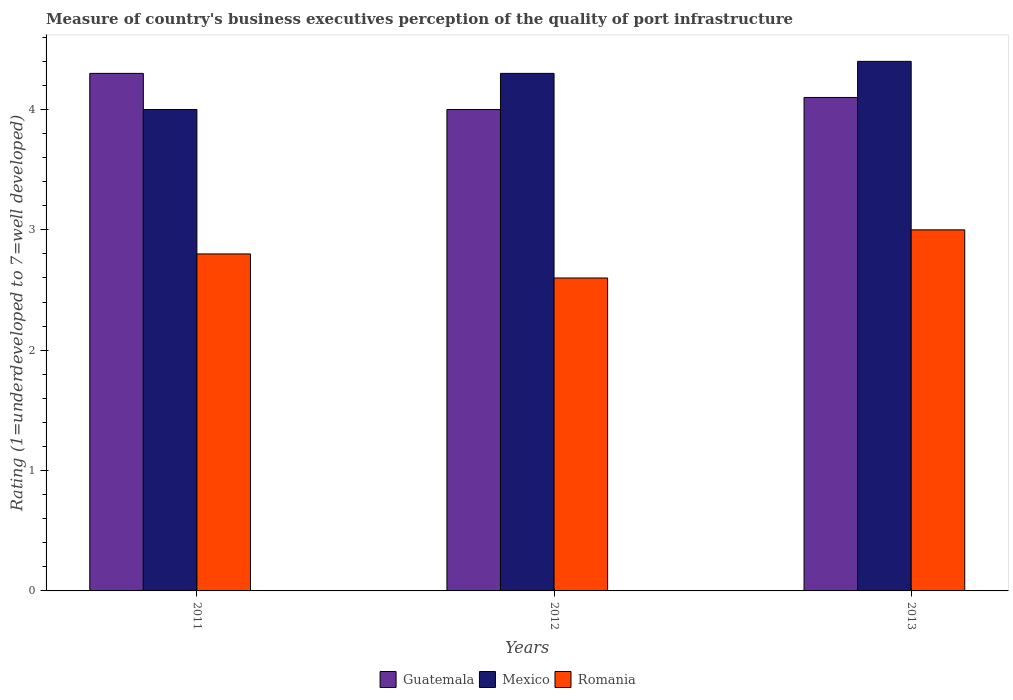Are the number of bars on each tick of the X-axis equal?
Offer a very short reply. Yes. What is the label of the 2nd group of bars from the left?
Keep it short and to the point. 2012. What is the difference between the ratings of the quality of port infrastructure in Romania in 2011 and that in 2012?
Make the answer very short. 0.2. What is the difference between the ratings of the quality of port infrastructure in Guatemala in 2011 and the ratings of the quality of port infrastructure in Romania in 2013?
Give a very brief answer. 1.3. What is the average ratings of the quality of port infrastructure in Mexico per year?
Provide a short and direct response. 4.23. In the year 2013, what is the difference between the ratings of the quality of port infrastructure in Guatemala and ratings of the quality of port infrastructure in Mexico?
Give a very brief answer. -0.3. What is the ratio of the ratings of the quality of port infrastructure in Romania in 2011 to that in 2012?
Your response must be concise. 1.08. Is the ratings of the quality of port infrastructure in Guatemala in 2012 less than that in 2013?
Provide a short and direct response. Yes. What is the difference between the highest and the second highest ratings of the quality of port infrastructure in Guatemala?
Your answer should be very brief. 0.2. What is the difference between the highest and the lowest ratings of the quality of port infrastructure in Guatemala?
Your answer should be very brief. 0.3. In how many years, is the ratings of the quality of port infrastructure in Guatemala greater than the average ratings of the quality of port infrastructure in Guatemala taken over all years?
Offer a very short reply. 1. What does the 3rd bar from the left in 2012 represents?
Make the answer very short. Romania. What does the 3rd bar from the right in 2013 represents?
Give a very brief answer. Guatemala. How many bars are there?
Keep it short and to the point. 9. How many years are there in the graph?
Offer a very short reply. 3. What is the difference between two consecutive major ticks on the Y-axis?
Your response must be concise. 1. Are the values on the major ticks of Y-axis written in scientific E-notation?
Offer a terse response. No. Does the graph contain any zero values?
Offer a terse response. No. Where does the legend appear in the graph?
Your answer should be compact. Bottom center. How many legend labels are there?
Provide a short and direct response. 3. How are the legend labels stacked?
Give a very brief answer. Horizontal. What is the title of the graph?
Your response must be concise. Measure of country's business executives perception of the quality of port infrastructure. What is the label or title of the X-axis?
Offer a terse response. Years. What is the label or title of the Y-axis?
Provide a short and direct response. Rating (1=underdeveloped to 7=well developed). What is the Rating (1=underdeveloped to 7=well developed) of Guatemala in 2011?
Provide a succinct answer. 4.3. What is the Rating (1=underdeveloped to 7=well developed) of Mexico in 2011?
Your response must be concise. 4. What is the Rating (1=underdeveloped to 7=well developed) in Mexico in 2012?
Keep it short and to the point. 4.3. What is the Rating (1=underdeveloped to 7=well developed) of Mexico in 2013?
Keep it short and to the point. 4.4. Across all years, what is the maximum Rating (1=underdeveloped to 7=well developed) of Mexico?
Provide a short and direct response. 4.4. Across all years, what is the maximum Rating (1=underdeveloped to 7=well developed) in Romania?
Make the answer very short. 3. Across all years, what is the minimum Rating (1=underdeveloped to 7=well developed) of Mexico?
Your response must be concise. 4. Across all years, what is the minimum Rating (1=underdeveloped to 7=well developed) in Romania?
Offer a terse response. 2.6. What is the total Rating (1=underdeveloped to 7=well developed) of Guatemala in the graph?
Offer a terse response. 12.4. What is the total Rating (1=underdeveloped to 7=well developed) in Mexico in the graph?
Your answer should be very brief. 12.7. What is the difference between the Rating (1=underdeveloped to 7=well developed) in Guatemala in 2011 and that in 2012?
Ensure brevity in your answer.  0.3. What is the difference between the Rating (1=underdeveloped to 7=well developed) of Guatemala in 2011 and that in 2013?
Keep it short and to the point. 0.2. What is the difference between the Rating (1=underdeveloped to 7=well developed) in Mexico in 2011 and that in 2013?
Your response must be concise. -0.4. What is the difference between the Rating (1=underdeveloped to 7=well developed) of Mexico in 2012 and that in 2013?
Keep it short and to the point. -0.1. What is the difference between the Rating (1=underdeveloped to 7=well developed) in Guatemala in 2011 and the Rating (1=underdeveloped to 7=well developed) in Mexico in 2012?
Give a very brief answer. 0. What is the difference between the Rating (1=underdeveloped to 7=well developed) in Guatemala in 2011 and the Rating (1=underdeveloped to 7=well developed) in Romania in 2012?
Ensure brevity in your answer.  1.7. What is the difference between the Rating (1=underdeveloped to 7=well developed) of Mexico in 2011 and the Rating (1=underdeveloped to 7=well developed) of Romania in 2012?
Your answer should be very brief. 1.4. What is the difference between the Rating (1=underdeveloped to 7=well developed) of Guatemala in 2011 and the Rating (1=underdeveloped to 7=well developed) of Mexico in 2013?
Provide a short and direct response. -0.1. What is the difference between the Rating (1=underdeveloped to 7=well developed) of Guatemala in 2011 and the Rating (1=underdeveloped to 7=well developed) of Romania in 2013?
Your response must be concise. 1.3. What is the difference between the Rating (1=underdeveloped to 7=well developed) in Mexico in 2011 and the Rating (1=underdeveloped to 7=well developed) in Romania in 2013?
Offer a terse response. 1. What is the difference between the Rating (1=underdeveloped to 7=well developed) in Guatemala in 2012 and the Rating (1=underdeveloped to 7=well developed) in Mexico in 2013?
Offer a very short reply. -0.4. What is the difference between the Rating (1=underdeveloped to 7=well developed) in Guatemala in 2012 and the Rating (1=underdeveloped to 7=well developed) in Romania in 2013?
Offer a very short reply. 1. What is the difference between the Rating (1=underdeveloped to 7=well developed) in Mexico in 2012 and the Rating (1=underdeveloped to 7=well developed) in Romania in 2013?
Your answer should be very brief. 1.3. What is the average Rating (1=underdeveloped to 7=well developed) of Guatemala per year?
Provide a succinct answer. 4.13. What is the average Rating (1=underdeveloped to 7=well developed) of Mexico per year?
Keep it short and to the point. 4.23. What is the average Rating (1=underdeveloped to 7=well developed) of Romania per year?
Provide a short and direct response. 2.8. In the year 2011, what is the difference between the Rating (1=underdeveloped to 7=well developed) of Guatemala and Rating (1=underdeveloped to 7=well developed) of Romania?
Offer a terse response. 1.5. In the year 2012, what is the difference between the Rating (1=underdeveloped to 7=well developed) of Guatemala and Rating (1=underdeveloped to 7=well developed) of Mexico?
Your response must be concise. -0.3. In the year 2012, what is the difference between the Rating (1=underdeveloped to 7=well developed) of Mexico and Rating (1=underdeveloped to 7=well developed) of Romania?
Ensure brevity in your answer.  1.7. What is the ratio of the Rating (1=underdeveloped to 7=well developed) of Guatemala in 2011 to that in 2012?
Your answer should be very brief. 1.07. What is the ratio of the Rating (1=underdeveloped to 7=well developed) in Mexico in 2011 to that in 2012?
Offer a terse response. 0.93. What is the ratio of the Rating (1=underdeveloped to 7=well developed) of Romania in 2011 to that in 2012?
Provide a succinct answer. 1.08. What is the ratio of the Rating (1=underdeveloped to 7=well developed) of Guatemala in 2011 to that in 2013?
Your answer should be very brief. 1.05. What is the ratio of the Rating (1=underdeveloped to 7=well developed) of Mexico in 2011 to that in 2013?
Offer a terse response. 0.91. What is the ratio of the Rating (1=underdeveloped to 7=well developed) of Romania in 2011 to that in 2013?
Keep it short and to the point. 0.93. What is the ratio of the Rating (1=underdeveloped to 7=well developed) of Guatemala in 2012 to that in 2013?
Offer a very short reply. 0.98. What is the ratio of the Rating (1=underdeveloped to 7=well developed) of Mexico in 2012 to that in 2013?
Your response must be concise. 0.98. What is the ratio of the Rating (1=underdeveloped to 7=well developed) of Romania in 2012 to that in 2013?
Your response must be concise. 0.87. What is the difference between the highest and the second highest Rating (1=underdeveloped to 7=well developed) of Guatemala?
Make the answer very short. 0.2. What is the difference between the highest and the lowest Rating (1=underdeveloped to 7=well developed) of Guatemala?
Your answer should be compact. 0.3. 